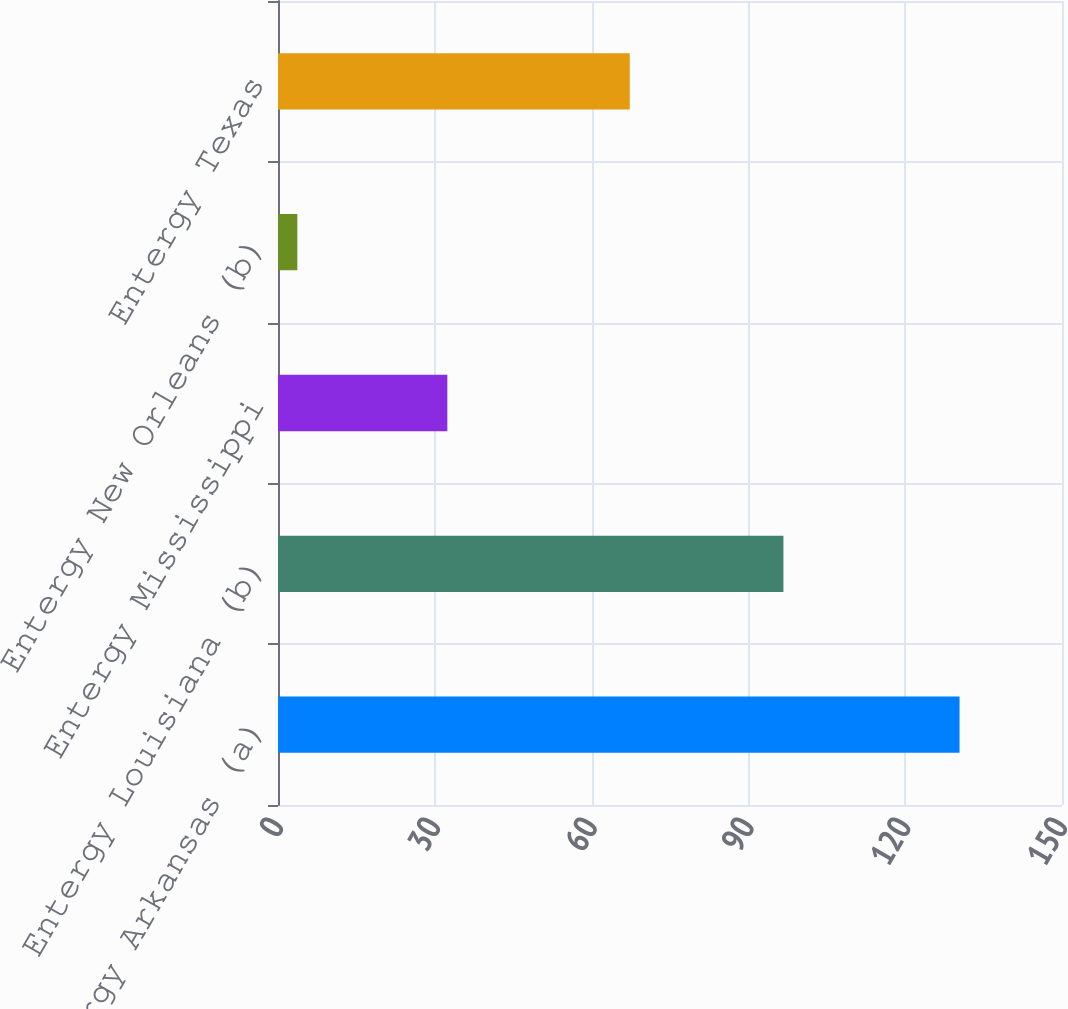Convert chart to OTSL. <chart><loc_0><loc_0><loc_500><loc_500><bar_chart><fcel>Entergy Arkansas (a)<fcel>Entergy Louisiana (b)<fcel>Entergy Mississippi<fcel>Entergy New Orleans (b)<fcel>Entergy Texas<nl><fcel>130.4<fcel>96.7<fcel>32.4<fcel>3.7<fcel>67.3<nl></chart> 